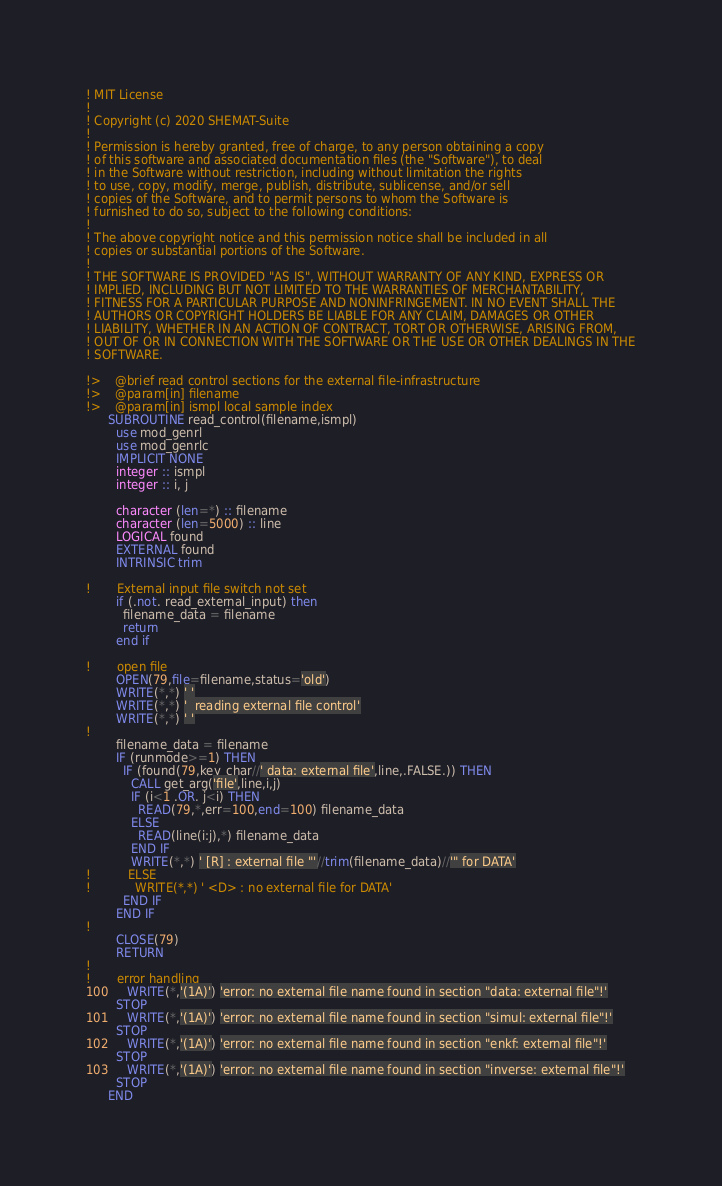Convert code to text. <code><loc_0><loc_0><loc_500><loc_500><_FORTRAN_>
! MIT License
!
! Copyright (c) 2020 SHEMAT-Suite
!
! Permission is hereby granted, free of charge, to any person obtaining a copy
! of this software and associated documentation files (the "Software"), to deal
! in the Software without restriction, including without limitation the rights
! to use, copy, modify, merge, publish, distribute, sublicense, and/or sell
! copies of the Software, and to permit persons to whom the Software is
! furnished to do so, subject to the following conditions:
!
! The above copyright notice and this permission notice shall be included in all
! copies or substantial portions of the Software.
!
! THE SOFTWARE IS PROVIDED "AS IS", WITHOUT WARRANTY OF ANY KIND, EXPRESS OR
! IMPLIED, INCLUDING BUT NOT LIMITED TO THE WARRANTIES OF MERCHANTABILITY,
! FITNESS FOR A PARTICULAR PURPOSE AND NONINFRINGEMENT. IN NO EVENT SHALL THE
! AUTHORS OR COPYRIGHT HOLDERS BE LIABLE FOR ANY CLAIM, DAMAGES OR OTHER
! LIABILITY, WHETHER IN AN ACTION OF CONTRACT, TORT OR OTHERWISE, ARISING FROM,
! OUT OF OR IN CONNECTION WITH THE SOFTWARE OR THE USE OR OTHER DEALINGS IN THE
! SOFTWARE.

!>    @brief read control sections for the external file-infrastructure
!>    @param[in] filename
!>    @param[in] ismpl local sample index
      SUBROUTINE read_control(filename,ismpl)
        use mod_genrl
        use mod_genrlc
        IMPLICIT NONE
        integer :: ismpl
        integer :: i, j

        character (len=*) :: filename
        character (len=5000) :: line
        LOGICAL found
        EXTERNAL found
        INTRINSIC trim

!       External input file switch not set
        if (.not. read_external_input) then
          filename_data = filename
          return
        end if

!       open file
        OPEN(79,file=filename,status='old')
        WRITE(*,*) ' '
        WRITE(*,*) '  reading external file control'
        WRITE(*,*) ' '
!
        filename_data = filename
        IF (runmode>=1) THEN
          IF (found(79,key_char//' data: external file',line,.FALSE.)) THEN
            CALL get_arg('file',line,i,j)
            IF (i<1 .OR. j<i) THEN
              READ(79,*,err=100,end=100) filename_data
            ELSE
              READ(line(i:j),*) filename_data
            END IF
            WRITE(*,*) ' [R] : external file "'//trim(filename_data)//'" for DATA'
!          ELSE
!            WRITE(*,*) ' <D> : no external file for DATA'
          END IF
        END IF
!
        CLOSE(79)
        RETURN
!
!       error handling
100     WRITE(*,'(1A)') 'error: no external file name found in section "data: external file"!'
        STOP
101     WRITE(*,'(1A)') 'error: no external file name found in section "simul: external file"!'
        STOP
102     WRITE(*,'(1A)') 'error: no external file name found in section "enkf: external file"!'
        STOP
103     WRITE(*,'(1A)') 'error: no external file name found in section "inverse: external file"!'
        STOP
      END
</code> 